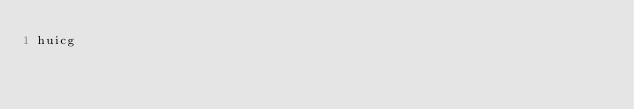<code> <loc_0><loc_0><loc_500><loc_500><_C++_>huicg</code> 